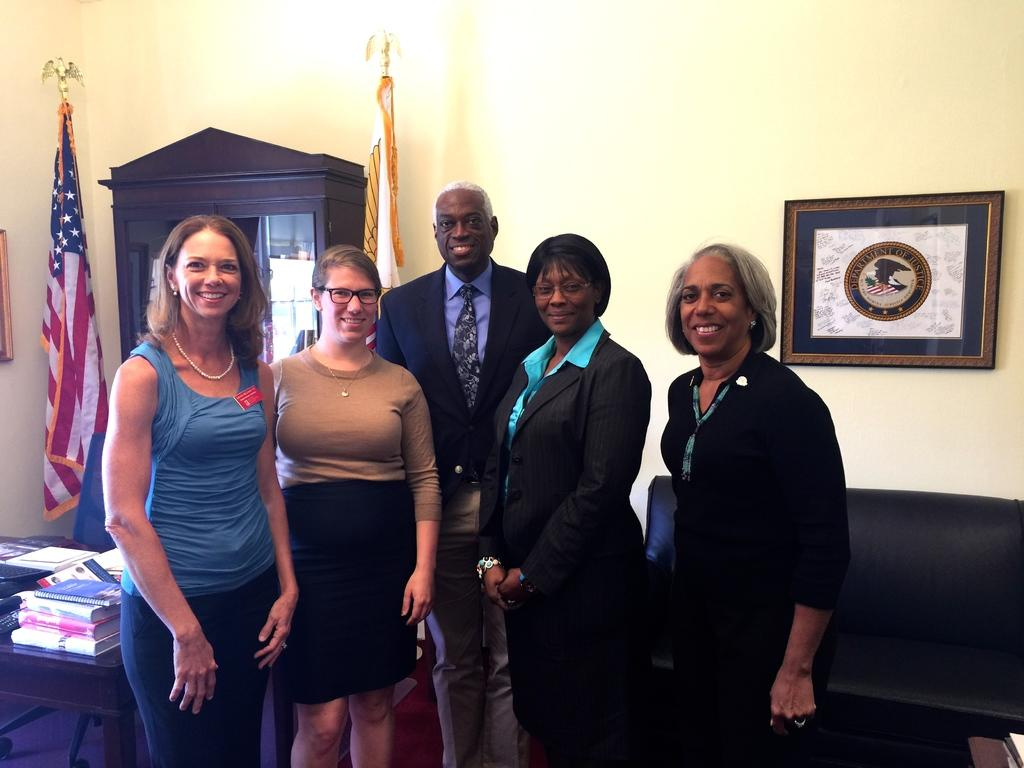What is the main focus of the image? The main focus of the image is the people in the center. What objects can be seen on the left side of the image? On the left side of the image, there are books, a chair, a table, a flag, and a bureau. What objects can be seen on the right side of the image? On the right side of the image, there are a couch, a table, books, and a frame. How many ladybugs are crawling on the couch in the image? There are no ladybugs present in the image. What type of muscle is visible in the image? There is no muscle visible in the image. 